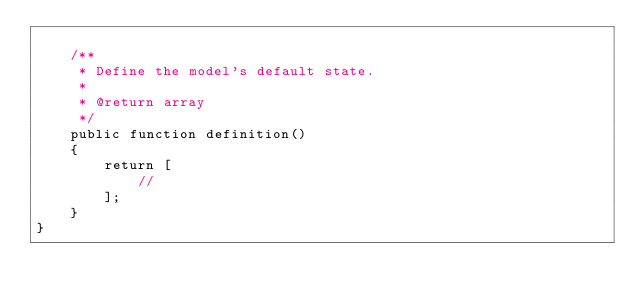<code> <loc_0><loc_0><loc_500><loc_500><_PHP_>
    /**
     * Define the model's default state.
     *
     * @return array
     */
    public function definition()
    {
        return [
            //
        ];
    }
}
</code> 